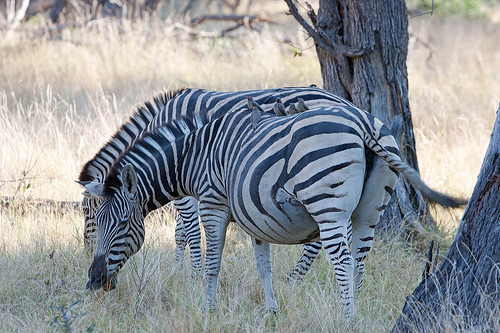Is there anything unusual about the patterns on these zebras? Each zebra has a unique stripe pattern, but nothing in this image suggests these particular zebras have unusual markings. The striping can vary widely among individuals, but all share the general characteristics of the species' pattern, which helps with camouflage, social bonding, and deterring insects and predators. 